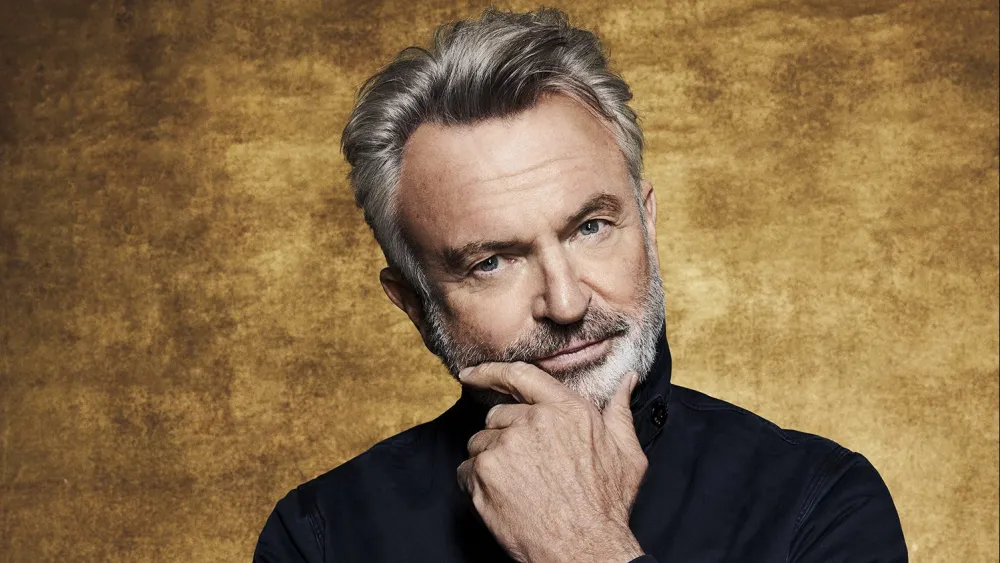What kind of mood does this image evoke? The image seems to evoke a reflective and serene mood. The subtle smile on the person's face combined with their thoughtful pose suggests a sense of calm introspection. The warmth of the gold background further accentuates this tranquil atmosphere. 